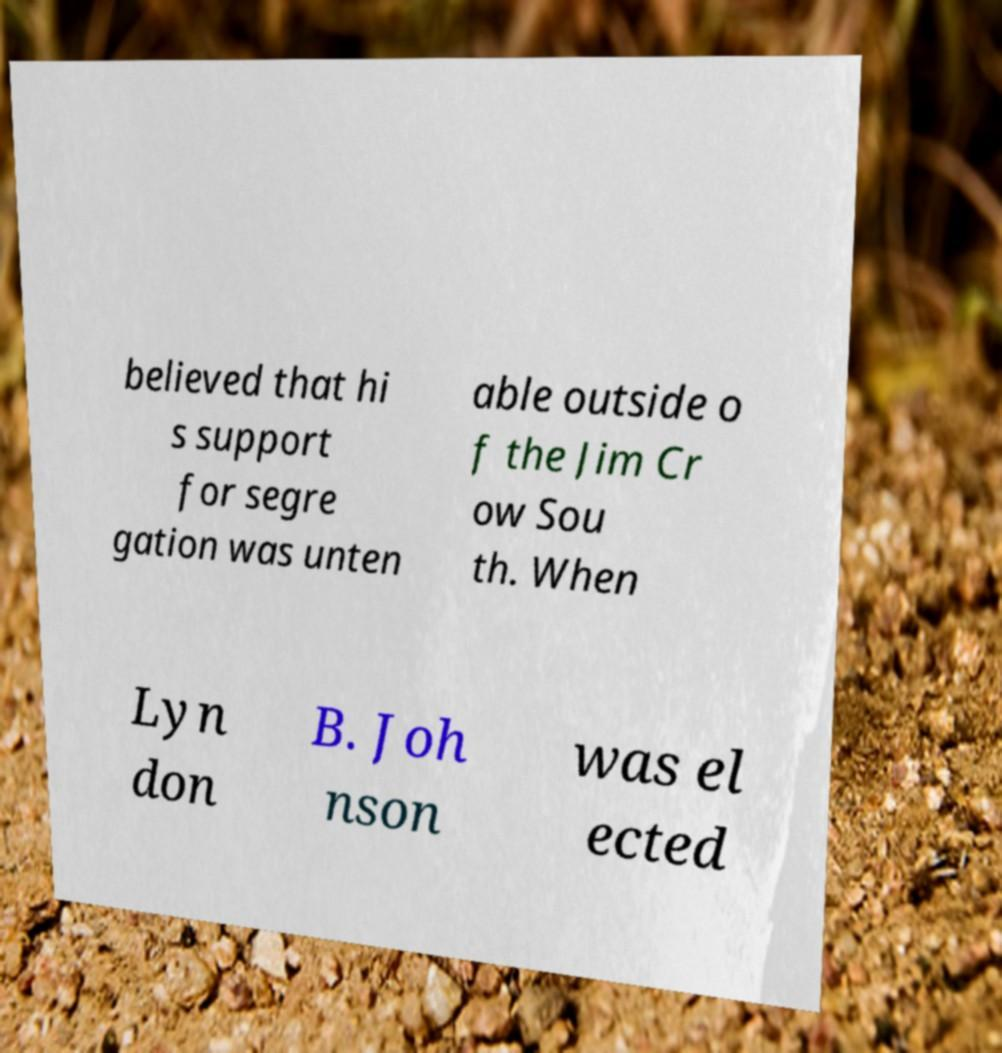What messages or text are displayed in this image? I need them in a readable, typed format. believed that hi s support for segre gation was unten able outside o f the Jim Cr ow Sou th. When Lyn don B. Joh nson was el ected 